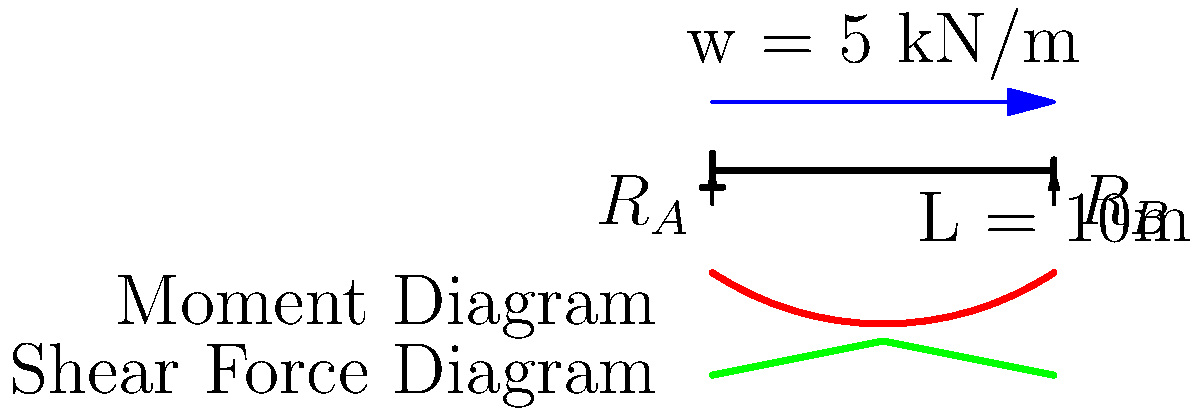A simply supported concrete beam of length 10m is subjected to a uniformly distributed load of 5 kN/m along its entire length. Calculate the maximum bending moment and shear force in the beam. How might these forces impact the stress distribution in the beam, and what holistic considerations would you suggest for maintaining the beam's long-term integrity? To solve this problem, we'll follow these steps:

1. Calculate the reactions at the supports:
   Total load = $5 \text{ kN/m} \times 10 \text{ m} = 50 \text{ kN}$
   Due to symmetry, $R_A = R_B = 50 \text{ kN} / 2 = 25 \text{ kN}$

2. Calculate the maximum bending moment:
   The maximum bending moment occurs at the center of the beam.
   $M_{max} = \frac{wL^2}{8} = \frac{5 \times 10^2}{8} = 62.5 \text{ kN·m}$

3. Calculate the maximum shear force:
   The maximum shear force occurs at the supports.
   $V_{max} = \frac{wL}{2} = \frac{5 \times 10}{2} = 25 \text{ kN}$

4. Stress distribution impact:
   The bending moment causes compressive stress in the top fibers and tensile stress in the bottom fibers of the beam. The shear force causes shear stress, which is maximum at the neutral axis of the beam.

5. Holistic considerations for long-term integrity:
   a) Material selection: Choose a concrete mix with appropriate strength and durability.
   b) Reinforcement: Provide adequate steel reinforcement to resist tensile stresses.
   c) Environmental factors: Consider exposure to moisture, temperature variations, and chemical agents.
   d) Load distribution: Ensure even distribution of loads to prevent stress concentrations.
   e) Regular inspections: Implement a maintenance schedule to detect early signs of deterioration.
   f) Stress reduction techniques: Consider using prestressing or post-tensioning to reduce tensile stresses.
   g) Holistic approach: Integrate traditional engineering practices with alternative methods like fiber-reinforced concrete or self-healing concrete technologies.
Answer: Maximum bending moment: 62.5 kN·m; Maximum shear force: 25 kN. Stress distribution: compression (top), tension (bottom), maximum shear at neutral axis. Holistic considerations: material selection, reinforcement, environmental factors, load distribution, regular inspections, stress reduction techniques, and integration of traditional and alternative methods. 